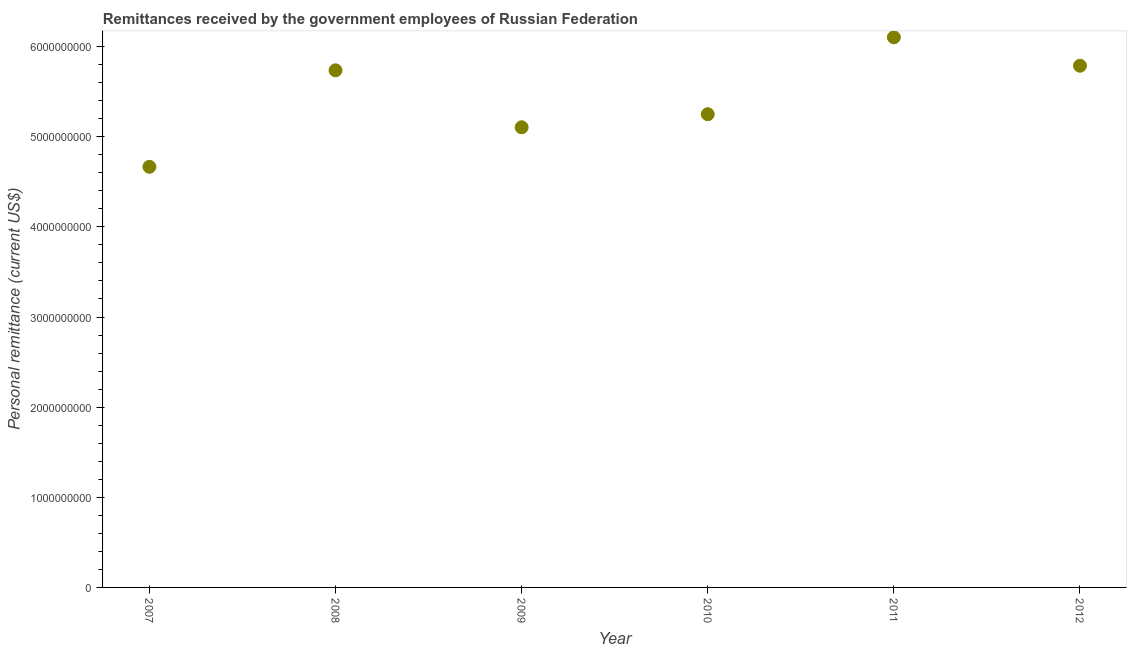What is the personal remittances in 2009?
Keep it short and to the point. 5.11e+09. Across all years, what is the maximum personal remittances?
Ensure brevity in your answer.  6.10e+09. Across all years, what is the minimum personal remittances?
Your answer should be very brief. 4.67e+09. In which year was the personal remittances maximum?
Your answer should be very brief. 2011. In which year was the personal remittances minimum?
Offer a terse response. 2007. What is the sum of the personal remittances?
Make the answer very short. 3.26e+1. What is the difference between the personal remittances in 2009 and 2010?
Offer a very short reply. -1.45e+08. What is the average personal remittances per year?
Your answer should be very brief. 5.44e+09. What is the median personal remittances?
Make the answer very short. 5.49e+09. In how many years, is the personal remittances greater than 200000000 US$?
Ensure brevity in your answer.  6. Do a majority of the years between 2011 and 2008 (inclusive) have personal remittances greater than 5200000000 US$?
Your answer should be very brief. Yes. What is the ratio of the personal remittances in 2007 to that in 2012?
Give a very brief answer. 0.81. Is the personal remittances in 2007 less than that in 2010?
Ensure brevity in your answer.  Yes. Is the difference between the personal remittances in 2011 and 2012 greater than the difference between any two years?
Keep it short and to the point. No. What is the difference between the highest and the second highest personal remittances?
Provide a succinct answer. 3.16e+08. Is the sum of the personal remittances in 2007 and 2009 greater than the maximum personal remittances across all years?
Provide a short and direct response. Yes. What is the difference between the highest and the lowest personal remittances?
Your answer should be very brief. 1.44e+09. Does the personal remittances monotonically increase over the years?
Your answer should be compact. No. How many dotlines are there?
Ensure brevity in your answer.  1. What is the difference between two consecutive major ticks on the Y-axis?
Your answer should be compact. 1.00e+09. Are the values on the major ticks of Y-axis written in scientific E-notation?
Offer a terse response. No. Does the graph contain grids?
Provide a succinct answer. No. What is the title of the graph?
Provide a succinct answer. Remittances received by the government employees of Russian Federation. What is the label or title of the Y-axis?
Keep it short and to the point. Personal remittance (current US$). What is the Personal remittance (current US$) in 2007?
Provide a succinct answer. 4.67e+09. What is the Personal remittance (current US$) in 2008?
Your response must be concise. 5.74e+09. What is the Personal remittance (current US$) in 2009?
Your answer should be compact. 5.11e+09. What is the Personal remittance (current US$) in 2010?
Offer a terse response. 5.25e+09. What is the Personal remittance (current US$) in 2011?
Offer a very short reply. 6.10e+09. What is the Personal remittance (current US$) in 2012?
Offer a very short reply. 5.79e+09. What is the difference between the Personal remittance (current US$) in 2007 and 2008?
Provide a short and direct response. -1.07e+09. What is the difference between the Personal remittance (current US$) in 2007 and 2009?
Offer a terse response. -4.39e+08. What is the difference between the Personal remittance (current US$) in 2007 and 2010?
Offer a terse response. -5.84e+08. What is the difference between the Personal remittance (current US$) in 2007 and 2011?
Provide a short and direct response. -1.44e+09. What is the difference between the Personal remittance (current US$) in 2007 and 2012?
Give a very brief answer. -1.12e+09. What is the difference between the Personal remittance (current US$) in 2008 and 2009?
Your answer should be very brief. 6.32e+08. What is the difference between the Personal remittance (current US$) in 2008 and 2010?
Your answer should be very brief. 4.87e+08. What is the difference between the Personal remittance (current US$) in 2008 and 2011?
Your answer should be compact. -3.66e+08. What is the difference between the Personal remittance (current US$) in 2008 and 2012?
Your answer should be compact. -5.08e+07. What is the difference between the Personal remittance (current US$) in 2009 and 2010?
Your answer should be very brief. -1.45e+08. What is the difference between the Personal remittance (current US$) in 2009 and 2011?
Ensure brevity in your answer.  -9.98e+08. What is the difference between the Personal remittance (current US$) in 2009 and 2012?
Your answer should be very brief. -6.83e+08. What is the difference between the Personal remittance (current US$) in 2010 and 2011?
Keep it short and to the point. -8.53e+08. What is the difference between the Personal remittance (current US$) in 2010 and 2012?
Give a very brief answer. -5.38e+08. What is the difference between the Personal remittance (current US$) in 2011 and 2012?
Your response must be concise. 3.16e+08. What is the ratio of the Personal remittance (current US$) in 2007 to that in 2008?
Make the answer very short. 0.81. What is the ratio of the Personal remittance (current US$) in 2007 to that in 2009?
Give a very brief answer. 0.91. What is the ratio of the Personal remittance (current US$) in 2007 to that in 2010?
Offer a very short reply. 0.89. What is the ratio of the Personal remittance (current US$) in 2007 to that in 2011?
Make the answer very short. 0.77. What is the ratio of the Personal remittance (current US$) in 2007 to that in 2012?
Ensure brevity in your answer.  0.81. What is the ratio of the Personal remittance (current US$) in 2008 to that in 2009?
Give a very brief answer. 1.12. What is the ratio of the Personal remittance (current US$) in 2008 to that in 2010?
Make the answer very short. 1.09. What is the ratio of the Personal remittance (current US$) in 2008 to that in 2012?
Make the answer very short. 0.99. What is the ratio of the Personal remittance (current US$) in 2009 to that in 2010?
Keep it short and to the point. 0.97. What is the ratio of the Personal remittance (current US$) in 2009 to that in 2011?
Provide a short and direct response. 0.84. What is the ratio of the Personal remittance (current US$) in 2009 to that in 2012?
Offer a very short reply. 0.88. What is the ratio of the Personal remittance (current US$) in 2010 to that in 2011?
Offer a terse response. 0.86. What is the ratio of the Personal remittance (current US$) in 2010 to that in 2012?
Your answer should be very brief. 0.91. What is the ratio of the Personal remittance (current US$) in 2011 to that in 2012?
Your response must be concise. 1.05. 